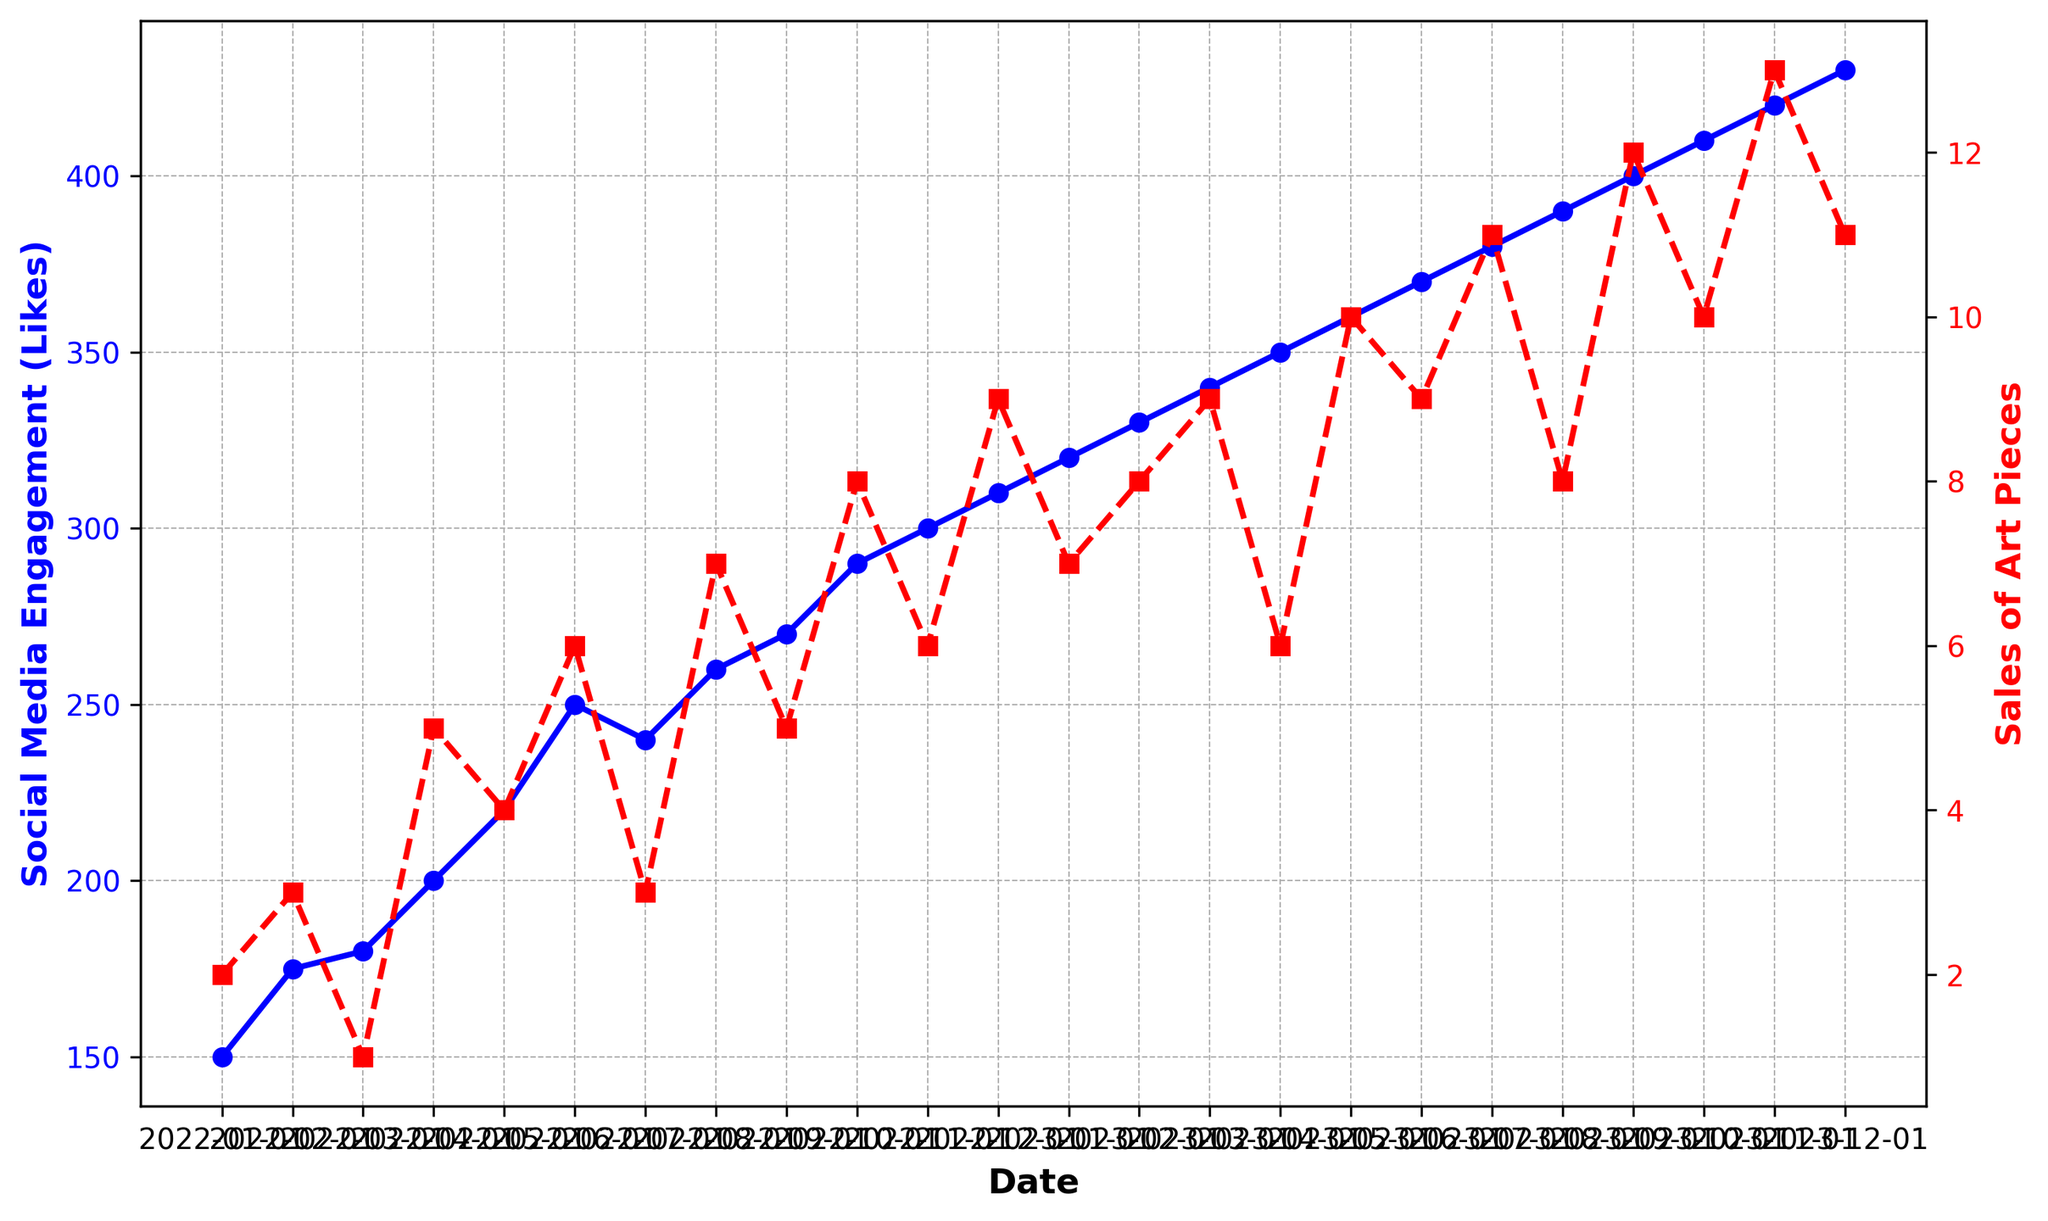Which month had the highest Social Media Engagement (Likes) and what was the corresponding value? The highest Social Media Engagement (Likes) occurred in December 2023 with a value of 430 Likes
Answer: December 2023, 430 Likes Which month had the highest Sales of Art Pieces and how many pieces were sold? The highest Sales of Art Pieces occurred in November 2023 with 13 pieces sold
Answer: November 2023, 13 pieces What is the difference in Social Media Engagement (Likes) between January 2022 and January 2023? Social Media Engagement (Likes) in January 2022 was 150, and in January 2023, it was 320. The difference is 320 - 150 = 170 Likes
Answer: 170 Likes Did any month have equal Social Media Engagement (Likes) and Sales of Art Pieces? By reviewing the plotted data, no month had the Social Media Engagement (Likes) value equal to the Sales of Art Pieces
Answer: No Compare the overall trends of Social Media Engagement (Likes) and Sales of Art Pieces from January 2022 to December 2023 Social Media Engagement shows a steady and gradual increase over time, while the Sales of Art Pieces exhibit more variability but an overall increasing trend
Answer: Both increasing, but Sales more variable How did the Sales of Art Pieces in February 2023 compare to February 2022? Sales of Art Pieces in February 2023 were 8, while in February 2022, they were 3. Therefore, sales increased by 5 pieces
Answer: Increased by 5 pieces What is the average number of Sales of Art Pieces per month in 2023? Sum the monthly sales of Art Pieces for 2023: 7+8+9+6+10+9+11+8+12+10+13+11 = 114. Average = 114/12 = 9.5
Answer: 9.5 pieces What are the respective growths in Social Media Engagement and Sales of Art Pieces from January 2022 to December 2023? Social Media Engagement increased from 150 Likes to 430 Likes. The growth is 430 - 150 = 280 Likes. Sales of Art Pieces increased from 2 to 11. The growth is 11 - 2 = 9 pieces
Answer: 280 Likes; 9 pieces At which points do Sales of Art Pieces peak and what are the corresponding values of Social Media Engagement at these points? Sales of Art Pieces peak in November 2023 with 13 pieces, corresponding Social Media Engagement is 420 Likes
Answer: November 2023: 420 Likes How do the Sales of Art Pieces in December 2022 compare with December 2023 and what are the respective Social Media Engagement values? Sales in December 2022 were 9, in December 2023 were 11. Social Media Engagement in December 2022 was 310 Likes, and in December 2023 was 430 Likes. So, sales increased by 2 pieces and engagement increased by 120 Likes
Answer: Sales increased by 2 pieces, Engagement increased by 120 Likes 